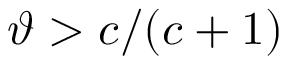<formula> <loc_0><loc_0><loc_500><loc_500>\vartheta > c / ( c + 1 )</formula> 